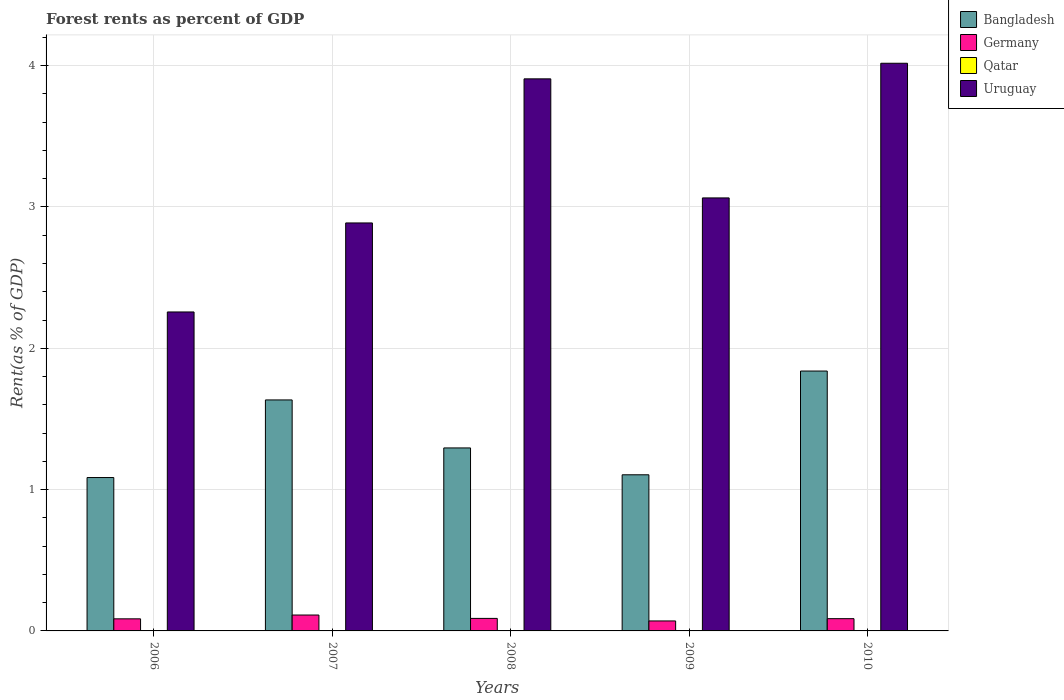How many groups of bars are there?
Keep it short and to the point. 5. Are the number of bars on each tick of the X-axis equal?
Your answer should be compact. Yes. What is the label of the 5th group of bars from the left?
Make the answer very short. 2010. What is the forest rent in Germany in 2009?
Your answer should be compact. 0.07. Across all years, what is the maximum forest rent in Germany?
Keep it short and to the point. 0.11. Across all years, what is the minimum forest rent in Qatar?
Make the answer very short. 0. In which year was the forest rent in Germany maximum?
Offer a very short reply. 2007. In which year was the forest rent in Bangladesh minimum?
Keep it short and to the point. 2006. What is the total forest rent in Germany in the graph?
Offer a very short reply. 0.44. What is the difference between the forest rent in Germany in 2006 and that in 2008?
Your response must be concise. -0. What is the difference between the forest rent in Bangladesh in 2010 and the forest rent in Qatar in 2009?
Ensure brevity in your answer.  1.84. What is the average forest rent in Bangladesh per year?
Your answer should be compact. 1.39. In the year 2009, what is the difference between the forest rent in Uruguay and forest rent in Qatar?
Offer a terse response. 3.06. What is the ratio of the forest rent in Qatar in 2008 to that in 2010?
Ensure brevity in your answer.  0.91. Is the forest rent in Germany in 2006 less than that in 2010?
Offer a terse response. Yes. What is the difference between the highest and the second highest forest rent in Bangladesh?
Provide a succinct answer. 0.2. What is the difference between the highest and the lowest forest rent in Uruguay?
Make the answer very short. 1.76. In how many years, is the forest rent in Germany greater than the average forest rent in Germany taken over all years?
Provide a succinct answer. 1. Is the sum of the forest rent in Germany in 2008 and 2009 greater than the maximum forest rent in Qatar across all years?
Offer a very short reply. Yes. What does the 3rd bar from the left in 2007 represents?
Keep it short and to the point. Qatar. What does the 4th bar from the right in 2008 represents?
Provide a short and direct response. Bangladesh. Is it the case that in every year, the sum of the forest rent in Uruguay and forest rent in Germany is greater than the forest rent in Bangladesh?
Your answer should be very brief. Yes. Are all the bars in the graph horizontal?
Offer a terse response. No. How many years are there in the graph?
Your answer should be very brief. 5. Are the values on the major ticks of Y-axis written in scientific E-notation?
Keep it short and to the point. No. Does the graph contain any zero values?
Ensure brevity in your answer.  No. Does the graph contain grids?
Provide a short and direct response. Yes. Where does the legend appear in the graph?
Keep it short and to the point. Top right. How many legend labels are there?
Your answer should be compact. 4. What is the title of the graph?
Make the answer very short. Forest rents as percent of GDP. Does "San Marino" appear as one of the legend labels in the graph?
Give a very brief answer. No. What is the label or title of the X-axis?
Provide a short and direct response. Years. What is the label or title of the Y-axis?
Provide a succinct answer. Rent(as % of GDP). What is the Rent(as % of GDP) in Bangladesh in 2006?
Your answer should be compact. 1.09. What is the Rent(as % of GDP) in Germany in 2006?
Your answer should be very brief. 0.09. What is the Rent(as % of GDP) of Qatar in 2006?
Make the answer very short. 0. What is the Rent(as % of GDP) of Uruguay in 2006?
Your answer should be compact. 2.26. What is the Rent(as % of GDP) in Bangladesh in 2007?
Provide a succinct answer. 1.63. What is the Rent(as % of GDP) in Germany in 2007?
Provide a short and direct response. 0.11. What is the Rent(as % of GDP) of Qatar in 2007?
Make the answer very short. 0. What is the Rent(as % of GDP) in Uruguay in 2007?
Your answer should be compact. 2.89. What is the Rent(as % of GDP) of Bangladesh in 2008?
Give a very brief answer. 1.3. What is the Rent(as % of GDP) of Germany in 2008?
Give a very brief answer. 0.09. What is the Rent(as % of GDP) of Qatar in 2008?
Your response must be concise. 0. What is the Rent(as % of GDP) in Uruguay in 2008?
Keep it short and to the point. 3.91. What is the Rent(as % of GDP) in Bangladesh in 2009?
Provide a short and direct response. 1.1. What is the Rent(as % of GDP) of Germany in 2009?
Provide a short and direct response. 0.07. What is the Rent(as % of GDP) of Qatar in 2009?
Your answer should be compact. 0. What is the Rent(as % of GDP) in Uruguay in 2009?
Your answer should be compact. 3.06. What is the Rent(as % of GDP) of Bangladesh in 2010?
Provide a short and direct response. 1.84. What is the Rent(as % of GDP) of Germany in 2010?
Provide a succinct answer. 0.09. What is the Rent(as % of GDP) of Qatar in 2010?
Give a very brief answer. 0. What is the Rent(as % of GDP) in Uruguay in 2010?
Your answer should be very brief. 4.02. Across all years, what is the maximum Rent(as % of GDP) in Bangladesh?
Offer a terse response. 1.84. Across all years, what is the maximum Rent(as % of GDP) in Germany?
Your response must be concise. 0.11. Across all years, what is the maximum Rent(as % of GDP) of Qatar?
Give a very brief answer. 0. Across all years, what is the maximum Rent(as % of GDP) of Uruguay?
Your answer should be compact. 4.02. Across all years, what is the minimum Rent(as % of GDP) of Bangladesh?
Your answer should be very brief. 1.09. Across all years, what is the minimum Rent(as % of GDP) of Germany?
Provide a succinct answer. 0.07. Across all years, what is the minimum Rent(as % of GDP) in Qatar?
Ensure brevity in your answer.  0. Across all years, what is the minimum Rent(as % of GDP) of Uruguay?
Keep it short and to the point. 2.26. What is the total Rent(as % of GDP) in Bangladesh in the graph?
Offer a very short reply. 6.96. What is the total Rent(as % of GDP) in Germany in the graph?
Keep it short and to the point. 0.44. What is the total Rent(as % of GDP) of Qatar in the graph?
Offer a terse response. 0. What is the total Rent(as % of GDP) in Uruguay in the graph?
Keep it short and to the point. 16.13. What is the difference between the Rent(as % of GDP) of Bangladesh in 2006 and that in 2007?
Make the answer very short. -0.55. What is the difference between the Rent(as % of GDP) of Germany in 2006 and that in 2007?
Offer a very short reply. -0.03. What is the difference between the Rent(as % of GDP) in Uruguay in 2006 and that in 2007?
Your answer should be compact. -0.63. What is the difference between the Rent(as % of GDP) of Bangladesh in 2006 and that in 2008?
Make the answer very short. -0.21. What is the difference between the Rent(as % of GDP) of Germany in 2006 and that in 2008?
Give a very brief answer. -0. What is the difference between the Rent(as % of GDP) in Uruguay in 2006 and that in 2008?
Your answer should be very brief. -1.65. What is the difference between the Rent(as % of GDP) of Bangladesh in 2006 and that in 2009?
Make the answer very short. -0.02. What is the difference between the Rent(as % of GDP) in Germany in 2006 and that in 2009?
Your answer should be very brief. 0.01. What is the difference between the Rent(as % of GDP) in Uruguay in 2006 and that in 2009?
Provide a short and direct response. -0.81. What is the difference between the Rent(as % of GDP) of Bangladesh in 2006 and that in 2010?
Offer a terse response. -0.75. What is the difference between the Rent(as % of GDP) of Germany in 2006 and that in 2010?
Offer a terse response. -0. What is the difference between the Rent(as % of GDP) in Qatar in 2006 and that in 2010?
Offer a terse response. -0. What is the difference between the Rent(as % of GDP) in Uruguay in 2006 and that in 2010?
Your answer should be compact. -1.76. What is the difference between the Rent(as % of GDP) in Bangladesh in 2007 and that in 2008?
Your response must be concise. 0.34. What is the difference between the Rent(as % of GDP) of Germany in 2007 and that in 2008?
Give a very brief answer. 0.02. What is the difference between the Rent(as % of GDP) of Uruguay in 2007 and that in 2008?
Provide a succinct answer. -1.02. What is the difference between the Rent(as % of GDP) of Bangladesh in 2007 and that in 2009?
Offer a very short reply. 0.53. What is the difference between the Rent(as % of GDP) in Germany in 2007 and that in 2009?
Ensure brevity in your answer.  0.04. What is the difference between the Rent(as % of GDP) in Qatar in 2007 and that in 2009?
Provide a short and direct response. -0. What is the difference between the Rent(as % of GDP) of Uruguay in 2007 and that in 2009?
Provide a short and direct response. -0.18. What is the difference between the Rent(as % of GDP) in Bangladesh in 2007 and that in 2010?
Offer a very short reply. -0.2. What is the difference between the Rent(as % of GDP) of Germany in 2007 and that in 2010?
Offer a terse response. 0.03. What is the difference between the Rent(as % of GDP) of Qatar in 2007 and that in 2010?
Offer a terse response. -0. What is the difference between the Rent(as % of GDP) of Uruguay in 2007 and that in 2010?
Your response must be concise. -1.13. What is the difference between the Rent(as % of GDP) in Bangladesh in 2008 and that in 2009?
Your answer should be very brief. 0.19. What is the difference between the Rent(as % of GDP) in Germany in 2008 and that in 2009?
Your answer should be very brief. 0.02. What is the difference between the Rent(as % of GDP) of Qatar in 2008 and that in 2009?
Your answer should be compact. -0. What is the difference between the Rent(as % of GDP) in Uruguay in 2008 and that in 2009?
Your answer should be very brief. 0.84. What is the difference between the Rent(as % of GDP) of Bangladesh in 2008 and that in 2010?
Your response must be concise. -0.54. What is the difference between the Rent(as % of GDP) of Germany in 2008 and that in 2010?
Keep it short and to the point. 0. What is the difference between the Rent(as % of GDP) of Uruguay in 2008 and that in 2010?
Keep it short and to the point. -0.11. What is the difference between the Rent(as % of GDP) of Bangladesh in 2009 and that in 2010?
Your answer should be compact. -0.73. What is the difference between the Rent(as % of GDP) of Germany in 2009 and that in 2010?
Make the answer very short. -0.02. What is the difference between the Rent(as % of GDP) of Uruguay in 2009 and that in 2010?
Your response must be concise. -0.95. What is the difference between the Rent(as % of GDP) in Bangladesh in 2006 and the Rent(as % of GDP) in Germany in 2007?
Make the answer very short. 0.97. What is the difference between the Rent(as % of GDP) in Bangladesh in 2006 and the Rent(as % of GDP) in Qatar in 2007?
Ensure brevity in your answer.  1.09. What is the difference between the Rent(as % of GDP) of Bangladesh in 2006 and the Rent(as % of GDP) of Uruguay in 2007?
Offer a terse response. -1.8. What is the difference between the Rent(as % of GDP) of Germany in 2006 and the Rent(as % of GDP) of Qatar in 2007?
Give a very brief answer. 0.09. What is the difference between the Rent(as % of GDP) of Germany in 2006 and the Rent(as % of GDP) of Uruguay in 2007?
Your answer should be very brief. -2.8. What is the difference between the Rent(as % of GDP) of Qatar in 2006 and the Rent(as % of GDP) of Uruguay in 2007?
Your answer should be compact. -2.89. What is the difference between the Rent(as % of GDP) in Bangladesh in 2006 and the Rent(as % of GDP) in Qatar in 2008?
Provide a short and direct response. 1.09. What is the difference between the Rent(as % of GDP) in Bangladesh in 2006 and the Rent(as % of GDP) in Uruguay in 2008?
Give a very brief answer. -2.82. What is the difference between the Rent(as % of GDP) in Germany in 2006 and the Rent(as % of GDP) in Qatar in 2008?
Make the answer very short. 0.09. What is the difference between the Rent(as % of GDP) in Germany in 2006 and the Rent(as % of GDP) in Uruguay in 2008?
Your response must be concise. -3.82. What is the difference between the Rent(as % of GDP) in Qatar in 2006 and the Rent(as % of GDP) in Uruguay in 2008?
Make the answer very short. -3.91. What is the difference between the Rent(as % of GDP) in Bangladesh in 2006 and the Rent(as % of GDP) in Germany in 2009?
Ensure brevity in your answer.  1.01. What is the difference between the Rent(as % of GDP) of Bangladesh in 2006 and the Rent(as % of GDP) of Qatar in 2009?
Offer a very short reply. 1.09. What is the difference between the Rent(as % of GDP) in Bangladesh in 2006 and the Rent(as % of GDP) in Uruguay in 2009?
Make the answer very short. -1.98. What is the difference between the Rent(as % of GDP) in Germany in 2006 and the Rent(as % of GDP) in Qatar in 2009?
Give a very brief answer. 0.09. What is the difference between the Rent(as % of GDP) in Germany in 2006 and the Rent(as % of GDP) in Uruguay in 2009?
Make the answer very short. -2.98. What is the difference between the Rent(as % of GDP) in Qatar in 2006 and the Rent(as % of GDP) in Uruguay in 2009?
Your response must be concise. -3.06. What is the difference between the Rent(as % of GDP) in Bangladesh in 2006 and the Rent(as % of GDP) in Qatar in 2010?
Provide a succinct answer. 1.09. What is the difference between the Rent(as % of GDP) in Bangladesh in 2006 and the Rent(as % of GDP) in Uruguay in 2010?
Your answer should be compact. -2.93. What is the difference between the Rent(as % of GDP) of Germany in 2006 and the Rent(as % of GDP) of Qatar in 2010?
Provide a succinct answer. 0.09. What is the difference between the Rent(as % of GDP) in Germany in 2006 and the Rent(as % of GDP) in Uruguay in 2010?
Your response must be concise. -3.93. What is the difference between the Rent(as % of GDP) in Qatar in 2006 and the Rent(as % of GDP) in Uruguay in 2010?
Offer a very short reply. -4.02. What is the difference between the Rent(as % of GDP) in Bangladesh in 2007 and the Rent(as % of GDP) in Germany in 2008?
Provide a succinct answer. 1.55. What is the difference between the Rent(as % of GDP) of Bangladesh in 2007 and the Rent(as % of GDP) of Qatar in 2008?
Your answer should be very brief. 1.63. What is the difference between the Rent(as % of GDP) of Bangladesh in 2007 and the Rent(as % of GDP) of Uruguay in 2008?
Provide a short and direct response. -2.27. What is the difference between the Rent(as % of GDP) of Germany in 2007 and the Rent(as % of GDP) of Qatar in 2008?
Provide a succinct answer. 0.11. What is the difference between the Rent(as % of GDP) of Germany in 2007 and the Rent(as % of GDP) of Uruguay in 2008?
Provide a short and direct response. -3.79. What is the difference between the Rent(as % of GDP) in Qatar in 2007 and the Rent(as % of GDP) in Uruguay in 2008?
Offer a very short reply. -3.91. What is the difference between the Rent(as % of GDP) of Bangladesh in 2007 and the Rent(as % of GDP) of Germany in 2009?
Keep it short and to the point. 1.56. What is the difference between the Rent(as % of GDP) in Bangladesh in 2007 and the Rent(as % of GDP) in Qatar in 2009?
Provide a succinct answer. 1.63. What is the difference between the Rent(as % of GDP) of Bangladesh in 2007 and the Rent(as % of GDP) of Uruguay in 2009?
Keep it short and to the point. -1.43. What is the difference between the Rent(as % of GDP) of Germany in 2007 and the Rent(as % of GDP) of Qatar in 2009?
Give a very brief answer. 0.11. What is the difference between the Rent(as % of GDP) of Germany in 2007 and the Rent(as % of GDP) of Uruguay in 2009?
Give a very brief answer. -2.95. What is the difference between the Rent(as % of GDP) of Qatar in 2007 and the Rent(as % of GDP) of Uruguay in 2009?
Your response must be concise. -3.06. What is the difference between the Rent(as % of GDP) in Bangladesh in 2007 and the Rent(as % of GDP) in Germany in 2010?
Your response must be concise. 1.55. What is the difference between the Rent(as % of GDP) of Bangladesh in 2007 and the Rent(as % of GDP) of Qatar in 2010?
Offer a very short reply. 1.63. What is the difference between the Rent(as % of GDP) of Bangladesh in 2007 and the Rent(as % of GDP) of Uruguay in 2010?
Keep it short and to the point. -2.38. What is the difference between the Rent(as % of GDP) of Germany in 2007 and the Rent(as % of GDP) of Qatar in 2010?
Your answer should be very brief. 0.11. What is the difference between the Rent(as % of GDP) of Germany in 2007 and the Rent(as % of GDP) of Uruguay in 2010?
Your answer should be compact. -3.9. What is the difference between the Rent(as % of GDP) of Qatar in 2007 and the Rent(as % of GDP) of Uruguay in 2010?
Offer a terse response. -4.02. What is the difference between the Rent(as % of GDP) of Bangladesh in 2008 and the Rent(as % of GDP) of Germany in 2009?
Ensure brevity in your answer.  1.22. What is the difference between the Rent(as % of GDP) in Bangladesh in 2008 and the Rent(as % of GDP) in Qatar in 2009?
Make the answer very short. 1.29. What is the difference between the Rent(as % of GDP) in Bangladesh in 2008 and the Rent(as % of GDP) in Uruguay in 2009?
Give a very brief answer. -1.77. What is the difference between the Rent(as % of GDP) in Germany in 2008 and the Rent(as % of GDP) in Qatar in 2009?
Make the answer very short. 0.09. What is the difference between the Rent(as % of GDP) in Germany in 2008 and the Rent(as % of GDP) in Uruguay in 2009?
Offer a terse response. -2.98. What is the difference between the Rent(as % of GDP) of Qatar in 2008 and the Rent(as % of GDP) of Uruguay in 2009?
Provide a short and direct response. -3.06. What is the difference between the Rent(as % of GDP) in Bangladesh in 2008 and the Rent(as % of GDP) in Germany in 2010?
Give a very brief answer. 1.21. What is the difference between the Rent(as % of GDP) in Bangladesh in 2008 and the Rent(as % of GDP) in Qatar in 2010?
Provide a succinct answer. 1.29. What is the difference between the Rent(as % of GDP) of Bangladesh in 2008 and the Rent(as % of GDP) of Uruguay in 2010?
Give a very brief answer. -2.72. What is the difference between the Rent(as % of GDP) in Germany in 2008 and the Rent(as % of GDP) in Qatar in 2010?
Your response must be concise. 0.09. What is the difference between the Rent(as % of GDP) in Germany in 2008 and the Rent(as % of GDP) in Uruguay in 2010?
Make the answer very short. -3.93. What is the difference between the Rent(as % of GDP) of Qatar in 2008 and the Rent(as % of GDP) of Uruguay in 2010?
Keep it short and to the point. -4.02. What is the difference between the Rent(as % of GDP) of Bangladesh in 2009 and the Rent(as % of GDP) of Germany in 2010?
Make the answer very short. 1.02. What is the difference between the Rent(as % of GDP) of Bangladesh in 2009 and the Rent(as % of GDP) of Qatar in 2010?
Make the answer very short. 1.1. What is the difference between the Rent(as % of GDP) in Bangladesh in 2009 and the Rent(as % of GDP) in Uruguay in 2010?
Keep it short and to the point. -2.91. What is the difference between the Rent(as % of GDP) in Germany in 2009 and the Rent(as % of GDP) in Qatar in 2010?
Provide a succinct answer. 0.07. What is the difference between the Rent(as % of GDP) in Germany in 2009 and the Rent(as % of GDP) in Uruguay in 2010?
Your answer should be compact. -3.95. What is the difference between the Rent(as % of GDP) of Qatar in 2009 and the Rent(as % of GDP) of Uruguay in 2010?
Your answer should be very brief. -4.02. What is the average Rent(as % of GDP) of Bangladesh per year?
Offer a terse response. 1.39. What is the average Rent(as % of GDP) of Germany per year?
Ensure brevity in your answer.  0.09. What is the average Rent(as % of GDP) of Qatar per year?
Your answer should be compact. 0. What is the average Rent(as % of GDP) in Uruguay per year?
Offer a very short reply. 3.23. In the year 2006, what is the difference between the Rent(as % of GDP) of Bangladesh and Rent(as % of GDP) of Qatar?
Keep it short and to the point. 1.09. In the year 2006, what is the difference between the Rent(as % of GDP) of Bangladesh and Rent(as % of GDP) of Uruguay?
Your answer should be very brief. -1.17. In the year 2006, what is the difference between the Rent(as % of GDP) of Germany and Rent(as % of GDP) of Qatar?
Your answer should be very brief. 0.09. In the year 2006, what is the difference between the Rent(as % of GDP) in Germany and Rent(as % of GDP) in Uruguay?
Make the answer very short. -2.17. In the year 2006, what is the difference between the Rent(as % of GDP) of Qatar and Rent(as % of GDP) of Uruguay?
Provide a short and direct response. -2.26. In the year 2007, what is the difference between the Rent(as % of GDP) in Bangladesh and Rent(as % of GDP) in Germany?
Offer a terse response. 1.52. In the year 2007, what is the difference between the Rent(as % of GDP) of Bangladesh and Rent(as % of GDP) of Qatar?
Provide a short and direct response. 1.63. In the year 2007, what is the difference between the Rent(as % of GDP) of Bangladesh and Rent(as % of GDP) of Uruguay?
Your answer should be very brief. -1.25. In the year 2007, what is the difference between the Rent(as % of GDP) of Germany and Rent(as % of GDP) of Qatar?
Your answer should be compact. 0.11. In the year 2007, what is the difference between the Rent(as % of GDP) in Germany and Rent(as % of GDP) in Uruguay?
Offer a very short reply. -2.77. In the year 2007, what is the difference between the Rent(as % of GDP) of Qatar and Rent(as % of GDP) of Uruguay?
Give a very brief answer. -2.89. In the year 2008, what is the difference between the Rent(as % of GDP) in Bangladesh and Rent(as % of GDP) in Germany?
Your response must be concise. 1.21. In the year 2008, what is the difference between the Rent(as % of GDP) in Bangladesh and Rent(as % of GDP) in Qatar?
Provide a short and direct response. 1.29. In the year 2008, what is the difference between the Rent(as % of GDP) in Bangladesh and Rent(as % of GDP) in Uruguay?
Keep it short and to the point. -2.61. In the year 2008, what is the difference between the Rent(as % of GDP) of Germany and Rent(as % of GDP) of Qatar?
Give a very brief answer. 0.09. In the year 2008, what is the difference between the Rent(as % of GDP) of Germany and Rent(as % of GDP) of Uruguay?
Provide a succinct answer. -3.82. In the year 2008, what is the difference between the Rent(as % of GDP) of Qatar and Rent(as % of GDP) of Uruguay?
Your answer should be compact. -3.91. In the year 2009, what is the difference between the Rent(as % of GDP) in Bangladesh and Rent(as % of GDP) in Germany?
Make the answer very short. 1.03. In the year 2009, what is the difference between the Rent(as % of GDP) in Bangladesh and Rent(as % of GDP) in Qatar?
Provide a short and direct response. 1.1. In the year 2009, what is the difference between the Rent(as % of GDP) in Bangladesh and Rent(as % of GDP) in Uruguay?
Your answer should be compact. -1.96. In the year 2009, what is the difference between the Rent(as % of GDP) of Germany and Rent(as % of GDP) of Qatar?
Give a very brief answer. 0.07. In the year 2009, what is the difference between the Rent(as % of GDP) of Germany and Rent(as % of GDP) of Uruguay?
Your answer should be compact. -2.99. In the year 2009, what is the difference between the Rent(as % of GDP) in Qatar and Rent(as % of GDP) in Uruguay?
Provide a short and direct response. -3.06. In the year 2010, what is the difference between the Rent(as % of GDP) in Bangladesh and Rent(as % of GDP) in Germany?
Offer a very short reply. 1.75. In the year 2010, what is the difference between the Rent(as % of GDP) in Bangladesh and Rent(as % of GDP) in Qatar?
Offer a terse response. 1.84. In the year 2010, what is the difference between the Rent(as % of GDP) in Bangladesh and Rent(as % of GDP) in Uruguay?
Ensure brevity in your answer.  -2.18. In the year 2010, what is the difference between the Rent(as % of GDP) of Germany and Rent(as % of GDP) of Qatar?
Offer a terse response. 0.09. In the year 2010, what is the difference between the Rent(as % of GDP) of Germany and Rent(as % of GDP) of Uruguay?
Your response must be concise. -3.93. In the year 2010, what is the difference between the Rent(as % of GDP) of Qatar and Rent(as % of GDP) of Uruguay?
Provide a short and direct response. -4.02. What is the ratio of the Rent(as % of GDP) of Bangladesh in 2006 to that in 2007?
Your answer should be very brief. 0.66. What is the ratio of the Rent(as % of GDP) in Germany in 2006 to that in 2007?
Your answer should be very brief. 0.76. What is the ratio of the Rent(as % of GDP) in Qatar in 2006 to that in 2007?
Give a very brief answer. 0.94. What is the ratio of the Rent(as % of GDP) of Uruguay in 2006 to that in 2007?
Your answer should be very brief. 0.78. What is the ratio of the Rent(as % of GDP) of Bangladesh in 2006 to that in 2008?
Provide a succinct answer. 0.84. What is the ratio of the Rent(as % of GDP) in Germany in 2006 to that in 2008?
Keep it short and to the point. 0.97. What is the ratio of the Rent(as % of GDP) in Qatar in 2006 to that in 2008?
Make the answer very short. 0.99. What is the ratio of the Rent(as % of GDP) in Uruguay in 2006 to that in 2008?
Provide a succinct answer. 0.58. What is the ratio of the Rent(as % of GDP) in Bangladesh in 2006 to that in 2009?
Provide a succinct answer. 0.98. What is the ratio of the Rent(as % of GDP) of Germany in 2006 to that in 2009?
Keep it short and to the point. 1.21. What is the ratio of the Rent(as % of GDP) in Qatar in 2006 to that in 2009?
Offer a very short reply. 0.89. What is the ratio of the Rent(as % of GDP) in Uruguay in 2006 to that in 2009?
Make the answer very short. 0.74. What is the ratio of the Rent(as % of GDP) of Bangladesh in 2006 to that in 2010?
Ensure brevity in your answer.  0.59. What is the ratio of the Rent(as % of GDP) of Germany in 2006 to that in 2010?
Provide a short and direct response. 0.99. What is the ratio of the Rent(as % of GDP) of Qatar in 2006 to that in 2010?
Your answer should be very brief. 0.9. What is the ratio of the Rent(as % of GDP) of Uruguay in 2006 to that in 2010?
Provide a short and direct response. 0.56. What is the ratio of the Rent(as % of GDP) in Bangladesh in 2007 to that in 2008?
Give a very brief answer. 1.26. What is the ratio of the Rent(as % of GDP) in Germany in 2007 to that in 2008?
Your response must be concise. 1.27. What is the ratio of the Rent(as % of GDP) of Qatar in 2007 to that in 2008?
Your answer should be very brief. 1.05. What is the ratio of the Rent(as % of GDP) in Uruguay in 2007 to that in 2008?
Your answer should be very brief. 0.74. What is the ratio of the Rent(as % of GDP) in Bangladesh in 2007 to that in 2009?
Provide a succinct answer. 1.48. What is the ratio of the Rent(as % of GDP) in Germany in 2007 to that in 2009?
Keep it short and to the point. 1.59. What is the ratio of the Rent(as % of GDP) of Qatar in 2007 to that in 2009?
Your response must be concise. 0.94. What is the ratio of the Rent(as % of GDP) of Uruguay in 2007 to that in 2009?
Give a very brief answer. 0.94. What is the ratio of the Rent(as % of GDP) of Bangladesh in 2007 to that in 2010?
Ensure brevity in your answer.  0.89. What is the ratio of the Rent(as % of GDP) in Germany in 2007 to that in 2010?
Keep it short and to the point. 1.3. What is the ratio of the Rent(as % of GDP) of Qatar in 2007 to that in 2010?
Offer a very short reply. 0.95. What is the ratio of the Rent(as % of GDP) of Uruguay in 2007 to that in 2010?
Provide a succinct answer. 0.72. What is the ratio of the Rent(as % of GDP) of Bangladesh in 2008 to that in 2009?
Offer a very short reply. 1.17. What is the ratio of the Rent(as % of GDP) of Germany in 2008 to that in 2009?
Your answer should be compact. 1.26. What is the ratio of the Rent(as % of GDP) in Qatar in 2008 to that in 2009?
Ensure brevity in your answer.  0.9. What is the ratio of the Rent(as % of GDP) in Uruguay in 2008 to that in 2009?
Give a very brief answer. 1.27. What is the ratio of the Rent(as % of GDP) of Bangladesh in 2008 to that in 2010?
Your answer should be compact. 0.7. What is the ratio of the Rent(as % of GDP) of Germany in 2008 to that in 2010?
Your answer should be very brief. 1.02. What is the ratio of the Rent(as % of GDP) in Qatar in 2008 to that in 2010?
Ensure brevity in your answer.  0.91. What is the ratio of the Rent(as % of GDP) of Uruguay in 2008 to that in 2010?
Give a very brief answer. 0.97. What is the ratio of the Rent(as % of GDP) of Bangladesh in 2009 to that in 2010?
Ensure brevity in your answer.  0.6. What is the ratio of the Rent(as % of GDP) of Germany in 2009 to that in 2010?
Offer a terse response. 0.81. What is the ratio of the Rent(as % of GDP) in Qatar in 2009 to that in 2010?
Offer a very short reply. 1.01. What is the ratio of the Rent(as % of GDP) of Uruguay in 2009 to that in 2010?
Give a very brief answer. 0.76. What is the difference between the highest and the second highest Rent(as % of GDP) of Bangladesh?
Offer a very short reply. 0.2. What is the difference between the highest and the second highest Rent(as % of GDP) of Germany?
Ensure brevity in your answer.  0.02. What is the difference between the highest and the second highest Rent(as % of GDP) of Qatar?
Keep it short and to the point. 0. What is the difference between the highest and the second highest Rent(as % of GDP) of Uruguay?
Your response must be concise. 0.11. What is the difference between the highest and the lowest Rent(as % of GDP) of Bangladesh?
Offer a very short reply. 0.75. What is the difference between the highest and the lowest Rent(as % of GDP) in Germany?
Your answer should be very brief. 0.04. What is the difference between the highest and the lowest Rent(as % of GDP) in Qatar?
Offer a very short reply. 0. What is the difference between the highest and the lowest Rent(as % of GDP) in Uruguay?
Make the answer very short. 1.76. 